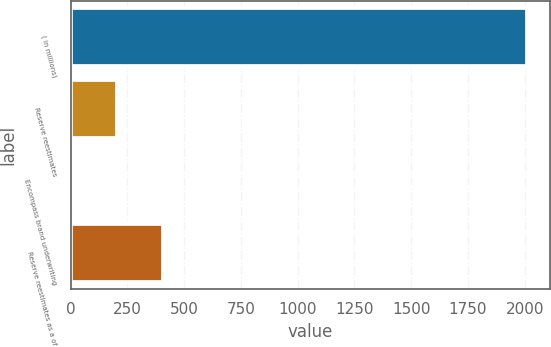Convert chart. <chart><loc_0><loc_0><loc_500><loc_500><bar_chart><fcel>( in millions)<fcel>Reserve reestimates<fcel>Encompass brand underwriting<fcel>Reserve reestimates as a of<nl><fcel>2009<fcel>205.4<fcel>5<fcel>405.8<nl></chart> 